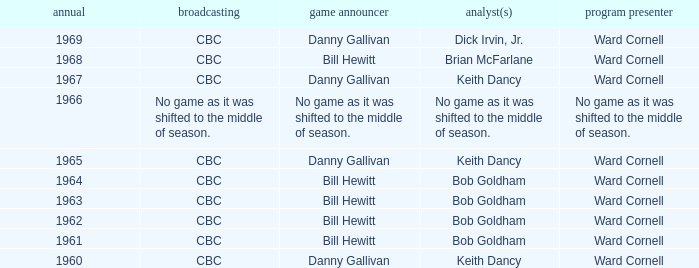Were the color commentators who worked with Bill Hewitt doing the play-by-play? Brian McFarlane, Bob Goldham, Bob Goldham, Bob Goldham, Bob Goldham. 